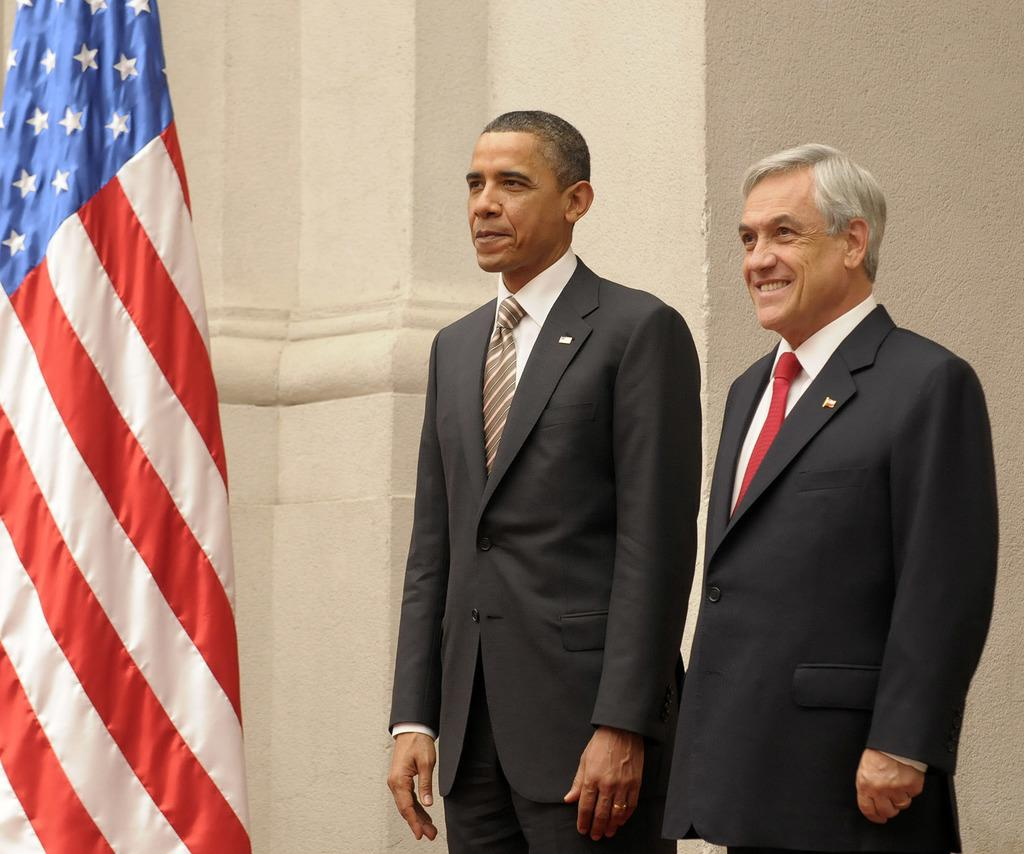How many men are in the image? There are two men in the image. What are the men wearing? Both men are wearing blazers and ties. What are the men doing in the image? The men are standing and smiling. What can be seen in the background of the image? There is a wall in the background of the image. What else is present in the image? There is a flag in the image. What type of pies are being served at the event in the image? There is no event or pies present in the image; it features two men standing and smiling. Can you see a ring on the finger of either man in the image? There is no ring visible on the fingers of the men in the image. 